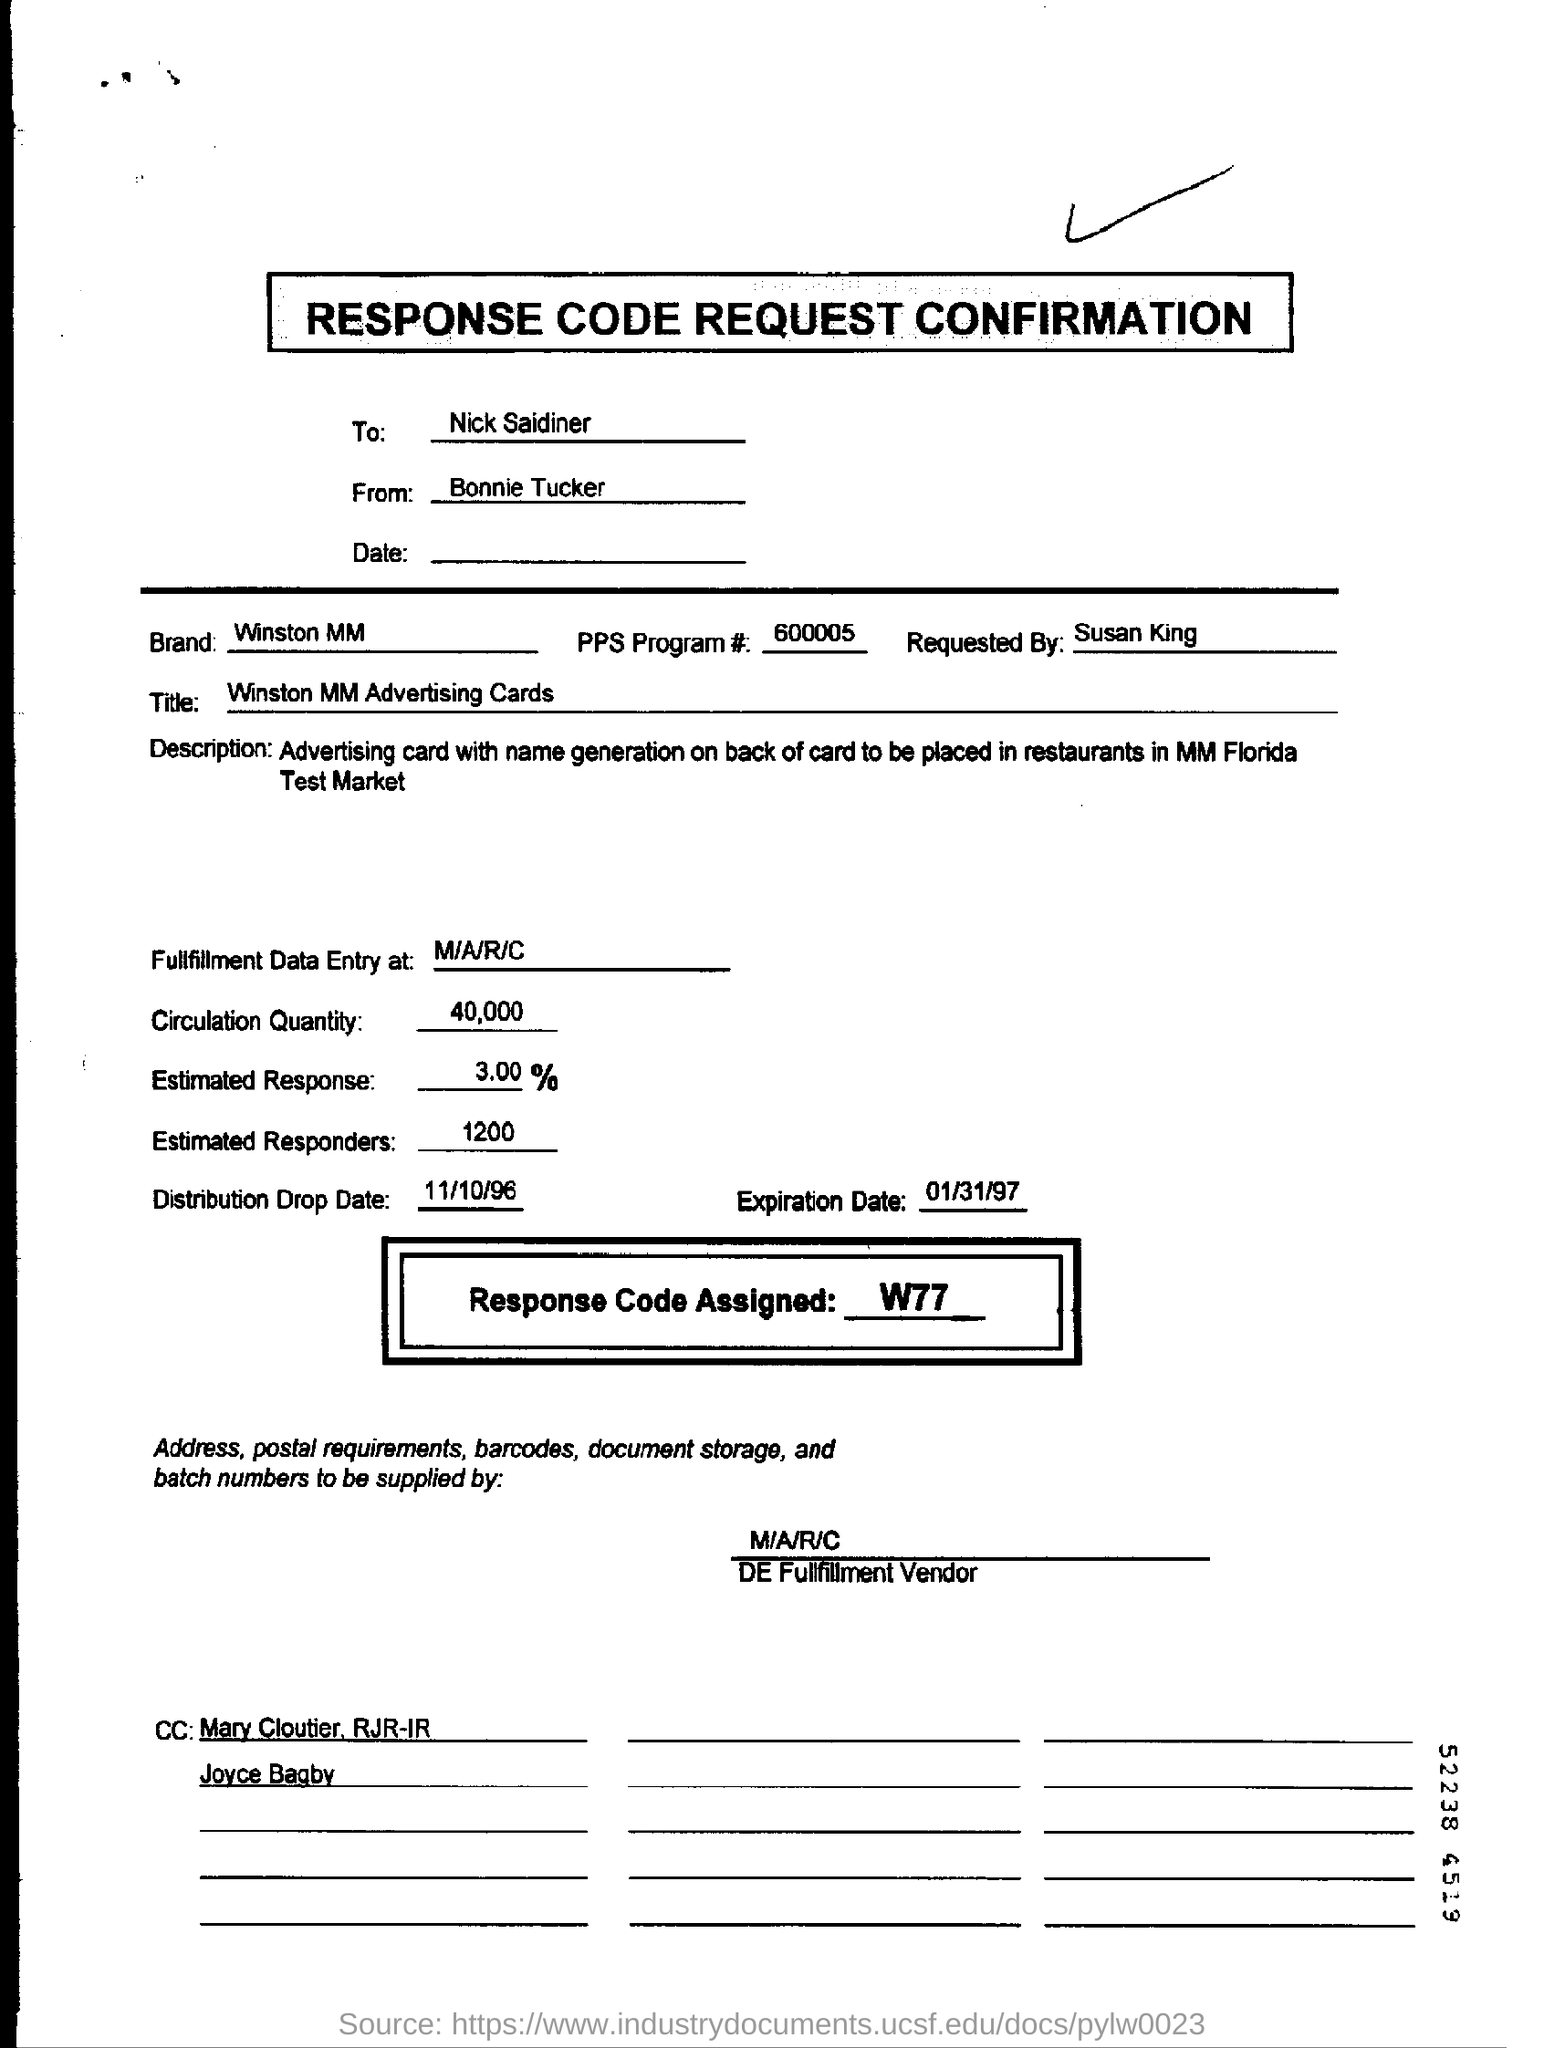Give some essential details in this illustration. The expiration date mentioned in the form is January 31st, 1997. 